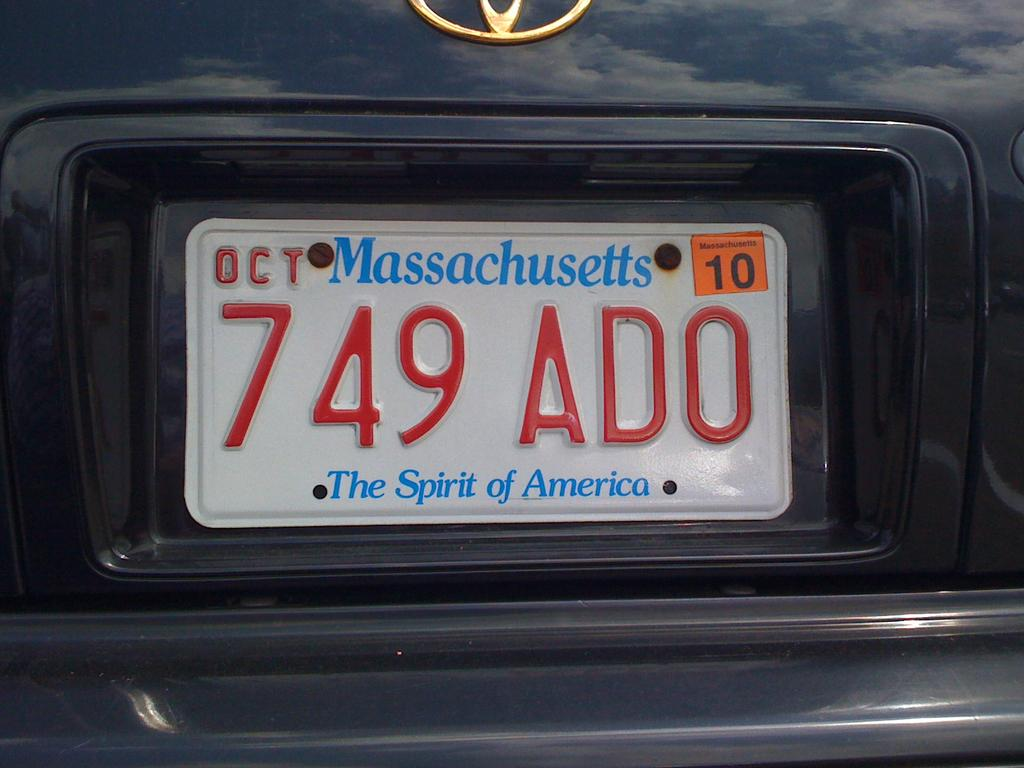<image>
Offer a succinct explanation of the picture presented. rear view of a car with Massachusetts car tag with the slogan "The Spirit of America 